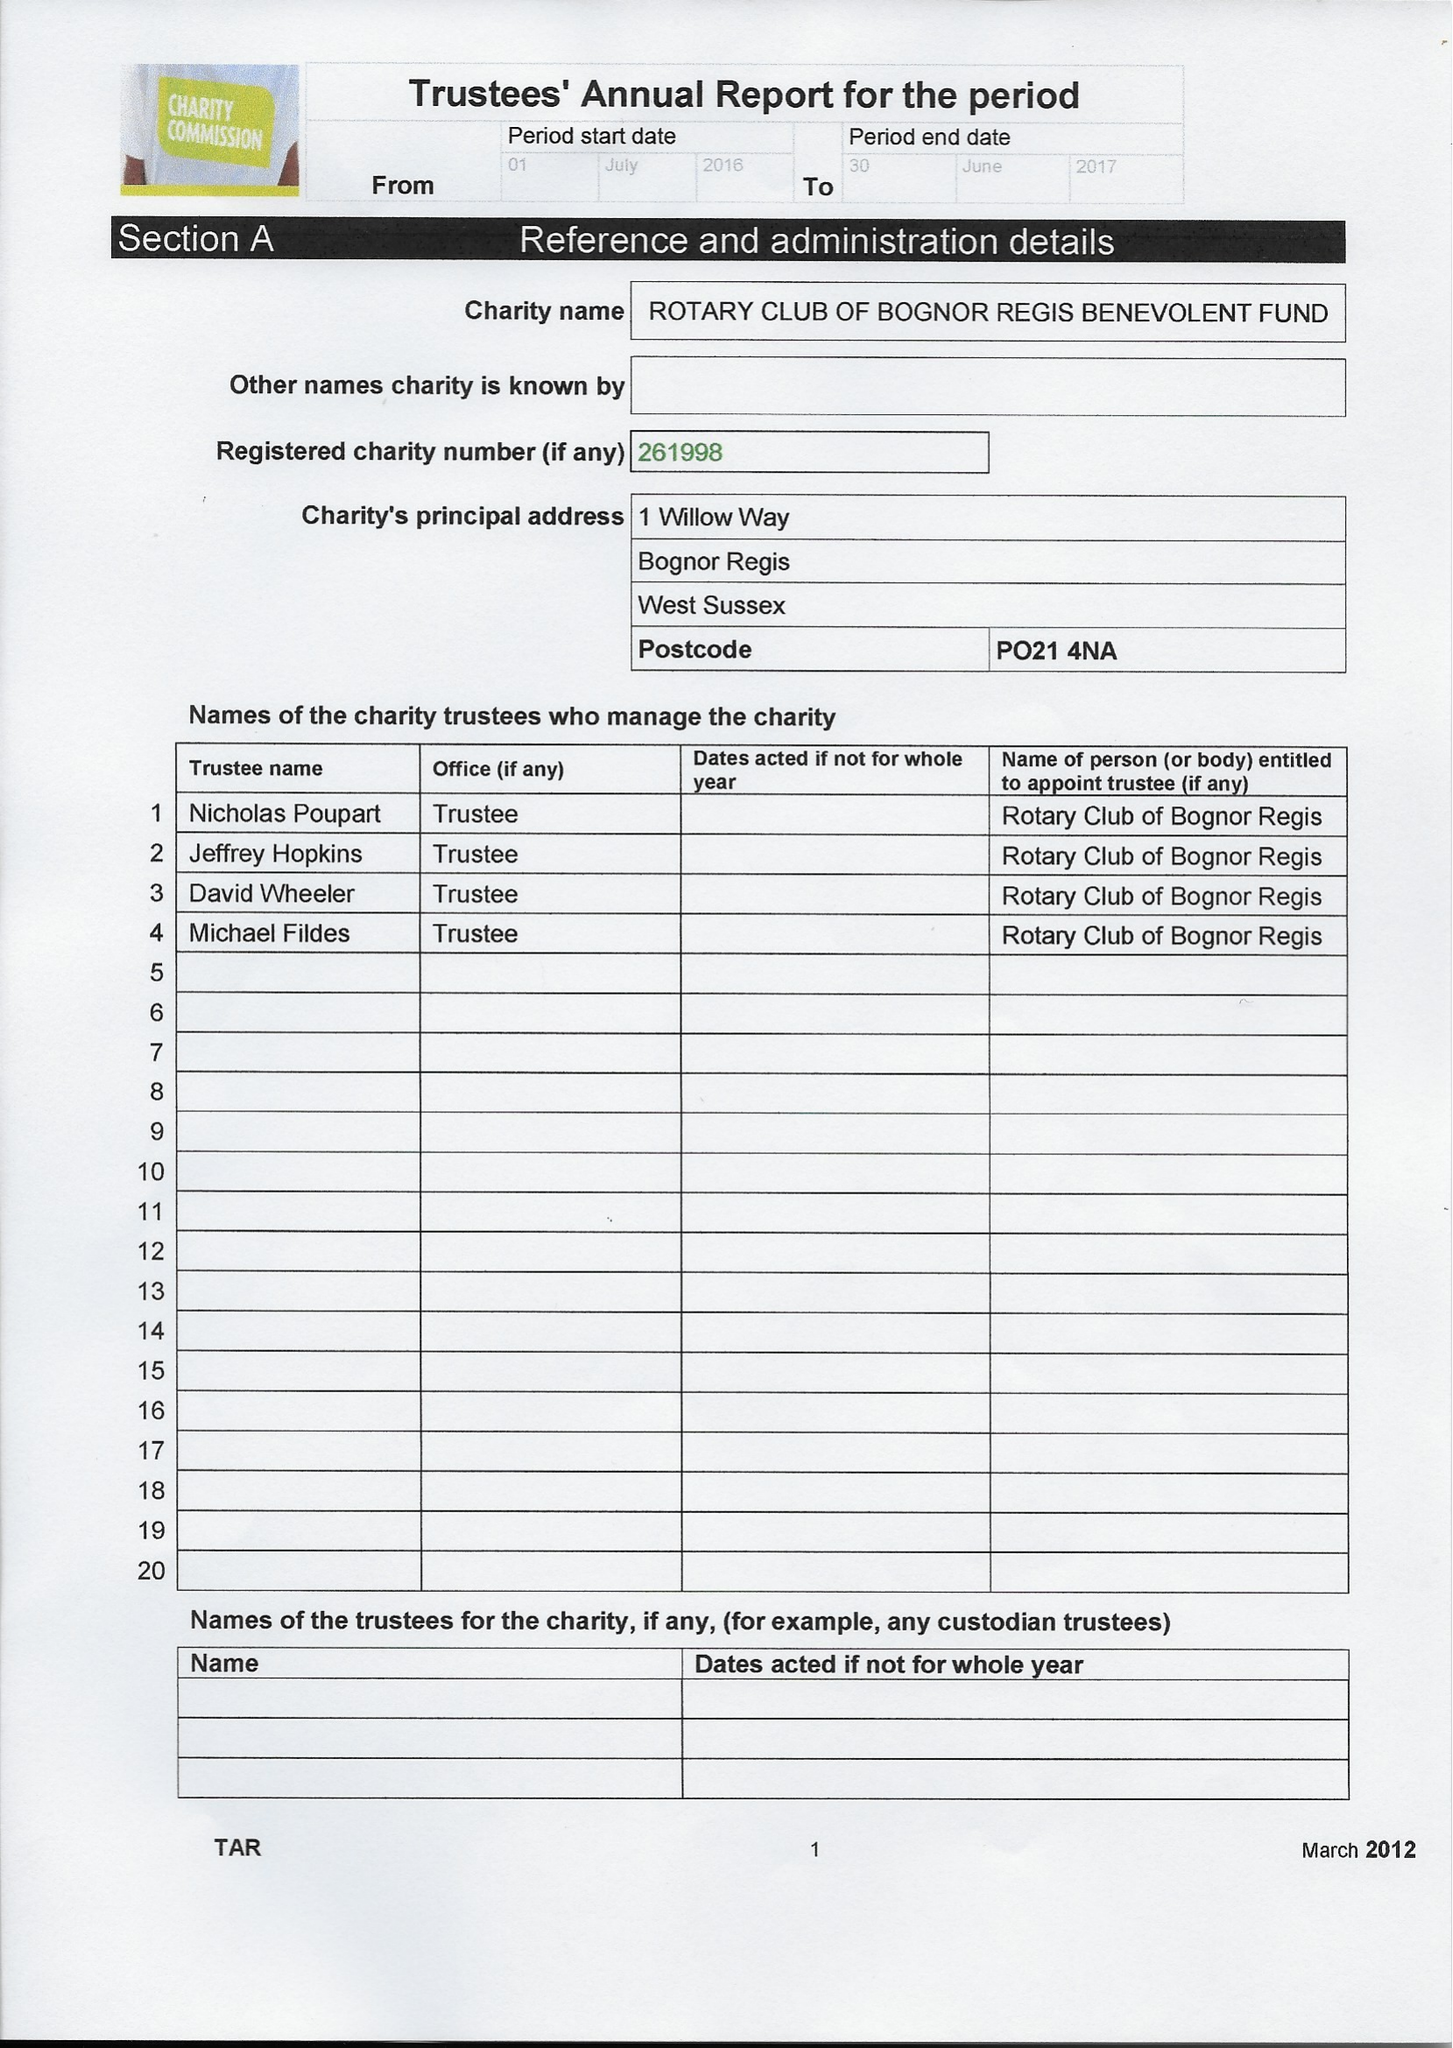What is the value for the income_annually_in_british_pounds?
Answer the question using a single word or phrase. 31869.31 